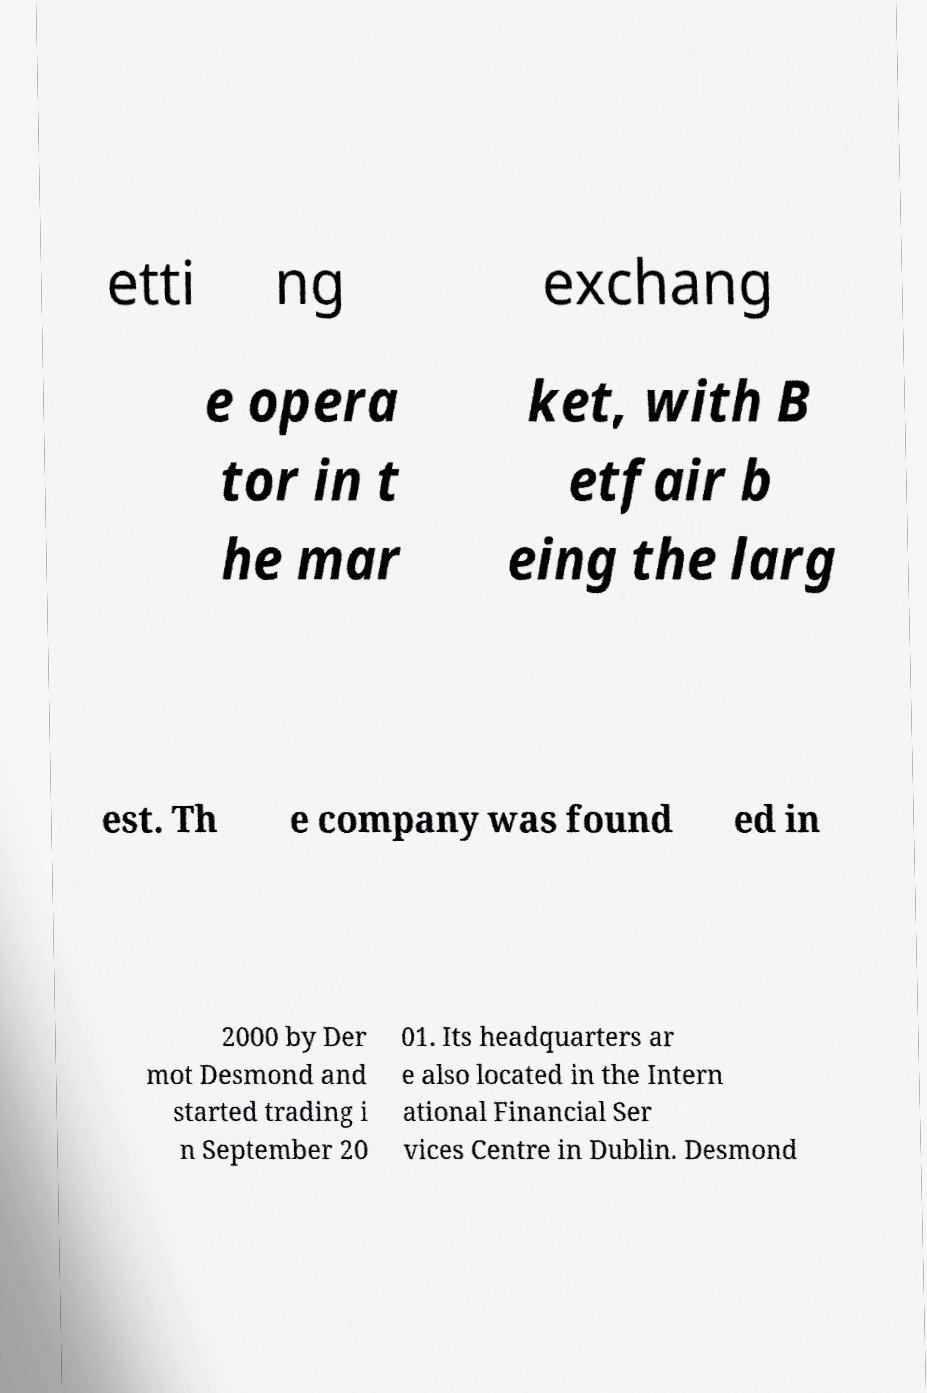What messages or text are displayed in this image? I need them in a readable, typed format. etti ng exchang e opera tor in t he mar ket, with B etfair b eing the larg est. Th e company was found ed in 2000 by Der mot Desmond and started trading i n September 20 01. Its headquarters ar e also located in the Intern ational Financial Ser vices Centre in Dublin. Desmond 